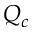<formula> <loc_0><loc_0><loc_500><loc_500>Q _ { c }</formula> 